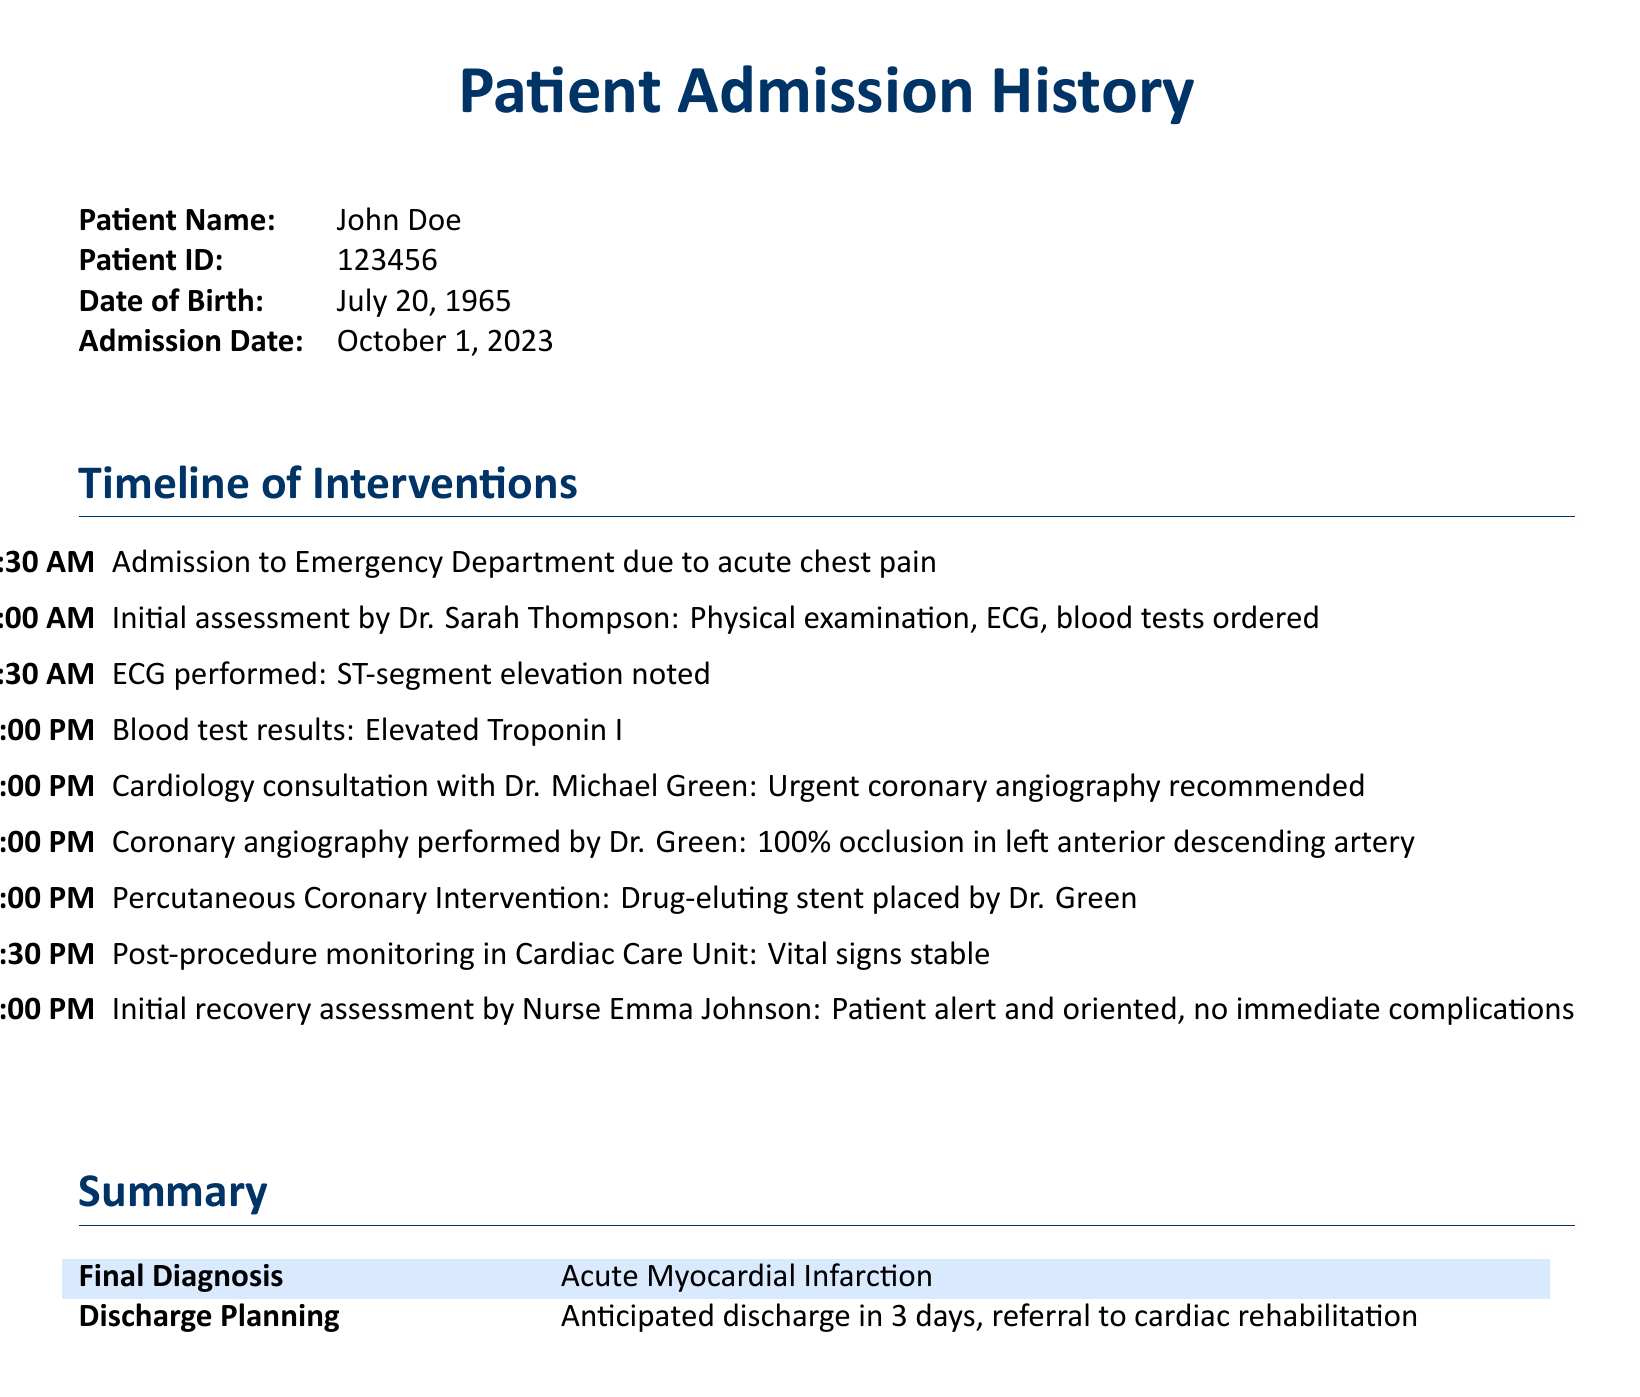What is the patient's name? The patient's name is specified at the beginning of the document.
Answer: John Doe What is the admission date? The admission date is given in the tabular section of the document.
Answer: October 1, 2023 Who performed the coronary angiography? The person who performed the procedure is noted in the timeline of interventions.
Answer: Dr. Green What was the final diagnosis? The final diagnosis is located in the summary table near the end of the document.
Answer: Acute Myocardial Infarction At what time was the initial recovery assessment performed? The time of the assessment is detailed in the timeline of interventions.
Answer: 6:00 PM How many minutes after admission was the ECG performed? The timeline shows the admission at 10:30 AM and ECG at 11:30 AM, which is one hour later.
Answer: 60 minutes What intervention was performed at 3:00 PM? The document specifies the intervention done at that time in the timeline.
Answer: Percutaneous Coronary Intervention What is the anticipated discharge timeline? The discharge planning section mentions how long until discharge.
Answer: 3 days 